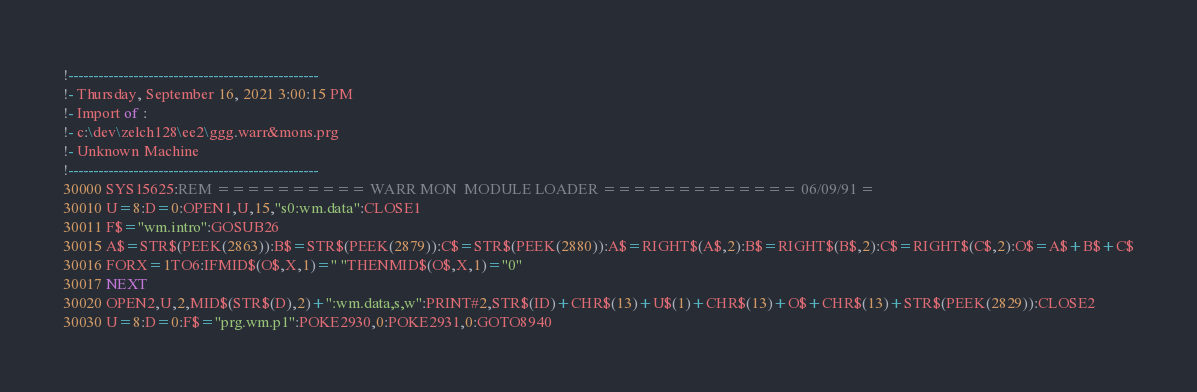Convert code to text. <code><loc_0><loc_0><loc_500><loc_500><_VisualBasic_>!--------------------------------------------------
!- Thursday, September 16, 2021 3:00:15 PM
!- Import of : 
!- c:\dev\zelch128\ee2\ggg.warr&mons.prg
!- Unknown Machine
!--------------------------------------------------
30000 SYS15625:REM ========== WARR MON  MODULE LOADER ============= 06/09/91 =
30010 U=8:D=0:OPEN1,U,15,"s0:wm.data":CLOSE1
30011 F$="wm.intro":GOSUB26
30015 A$=STR$(PEEK(2863)):B$=STR$(PEEK(2879)):C$=STR$(PEEK(2880)):A$=RIGHT$(A$,2):B$=RIGHT$(B$,2):C$=RIGHT$(C$,2):O$=A$+B$+C$
30016 FORX=1TO6:IFMID$(O$,X,1)=" "THENMID$(O$,X,1)="0"
30017 NEXT
30020 OPEN2,U,2,MID$(STR$(D),2)+":wm.data,s,w":PRINT#2,STR$(ID)+CHR$(13)+U$(1)+CHR$(13)+O$+CHR$(13)+STR$(PEEK(2829)):CLOSE2
30030 U=8:D=0:F$="prg.wm.p1":POKE2930,0:POKE2931,0:GOTO8940
</code> 